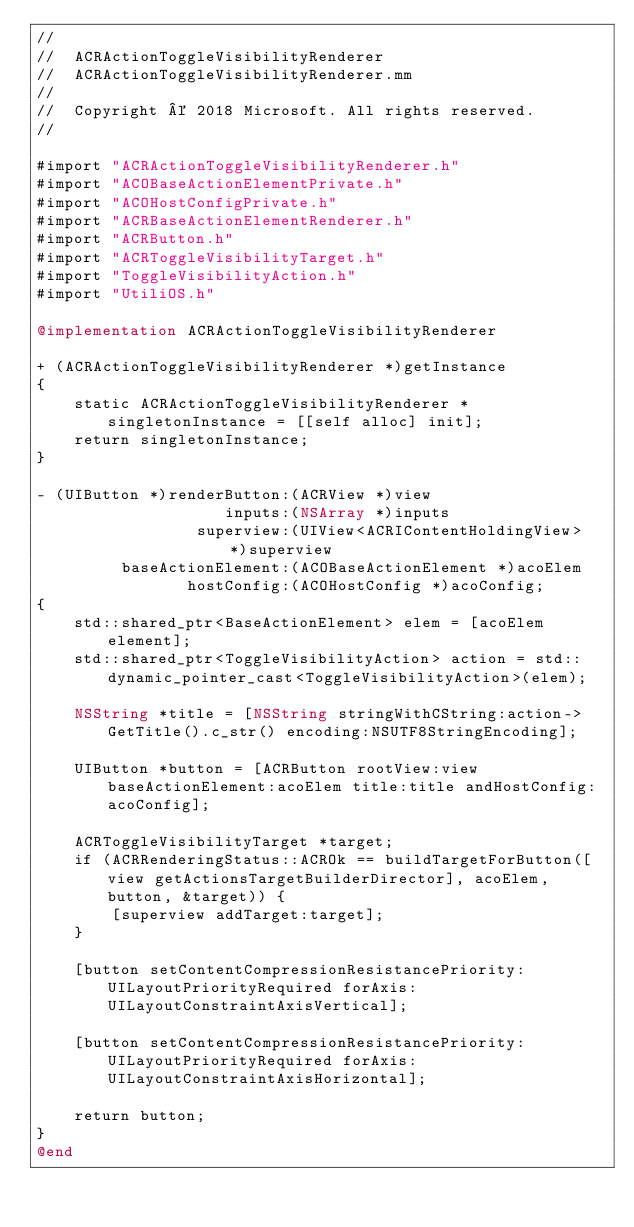<code> <loc_0><loc_0><loc_500><loc_500><_ObjectiveC_>//
//  ACRActionToggleVisibilityRenderer
//  ACRActionToggleVisibilityRenderer.mm
//
//  Copyright © 2018 Microsoft. All rights reserved.
//

#import "ACRActionToggleVisibilityRenderer.h"
#import "ACOBaseActionElementPrivate.h"
#import "ACOHostConfigPrivate.h"
#import "ACRBaseActionElementRenderer.h"
#import "ACRButton.h"
#import "ACRToggleVisibilityTarget.h"
#import "ToggleVisibilityAction.h"
#import "UtiliOS.h"

@implementation ACRActionToggleVisibilityRenderer

+ (ACRActionToggleVisibilityRenderer *)getInstance
{
    static ACRActionToggleVisibilityRenderer *singletonInstance = [[self alloc] init];
    return singletonInstance;
}

- (UIButton *)renderButton:(ACRView *)view
                    inputs:(NSArray *)inputs
                 superview:(UIView<ACRIContentHoldingView> *)superview
         baseActionElement:(ACOBaseActionElement *)acoElem
                hostConfig:(ACOHostConfig *)acoConfig;
{
    std::shared_ptr<BaseActionElement> elem = [acoElem element];
    std::shared_ptr<ToggleVisibilityAction> action = std::dynamic_pointer_cast<ToggleVisibilityAction>(elem);

    NSString *title = [NSString stringWithCString:action->GetTitle().c_str() encoding:NSUTF8StringEncoding];

    UIButton *button = [ACRButton rootView:view baseActionElement:acoElem title:title andHostConfig:acoConfig];

    ACRToggleVisibilityTarget *target;
    if (ACRRenderingStatus::ACROk == buildTargetForButton([view getActionsTargetBuilderDirector], acoElem, button, &target)) {
        [superview addTarget:target];
    }

    [button setContentCompressionResistancePriority:UILayoutPriorityRequired forAxis:UILayoutConstraintAxisVertical];

    [button setContentCompressionResistancePriority:UILayoutPriorityRequired forAxis:UILayoutConstraintAxisHorizontal];

    return button;
}
@end
</code> 